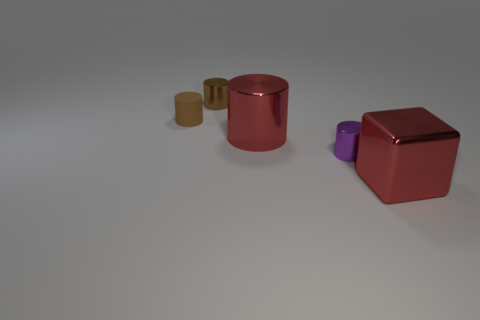What number of objects are either matte cylinders or cubes?
Offer a terse response. 2. How many tiny cylinders are both in front of the rubber object and behind the purple metallic cylinder?
Offer a terse response. 0. Are there fewer matte things that are in front of the tiny matte cylinder than big red rubber spheres?
Offer a very short reply. No. There is a red shiny thing that is the same size as the red shiny cylinder; what shape is it?
Your response must be concise. Cube. How many other things are the same color as the rubber object?
Keep it short and to the point. 1. Does the block have the same size as the brown rubber object?
Keep it short and to the point. No. How many objects are large cubes or objects that are right of the big red metallic cylinder?
Your answer should be very brief. 2. Is the number of metallic cylinders in front of the tiny matte object less than the number of small brown cylinders right of the red metal cylinder?
Ensure brevity in your answer.  No. How many other things are there of the same material as the purple cylinder?
Your response must be concise. 3. Do the large metal thing that is to the left of the large metallic cube and the big shiny block have the same color?
Your answer should be compact. Yes. 